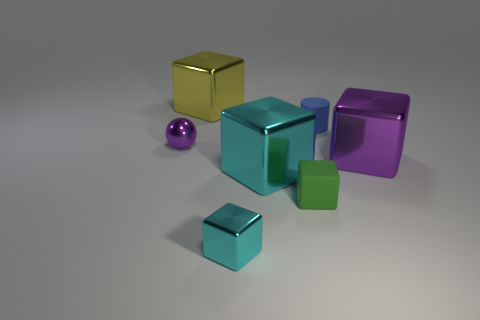Subtract all green cubes. How many cubes are left? 4 Subtract all small green rubber cubes. How many cubes are left? 4 Subtract all red blocks. Subtract all green cylinders. How many blocks are left? 5 Add 1 tiny shiny objects. How many objects exist? 8 Subtract all cubes. How many objects are left? 2 Subtract 0 green balls. How many objects are left? 7 Subtract all rubber objects. Subtract all small purple objects. How many objects are left? 4 Add 1 blue objects. How many blue objects are left? 2 Add 1 large purple matte blocks. How many large purple matte blocks exist? 1 